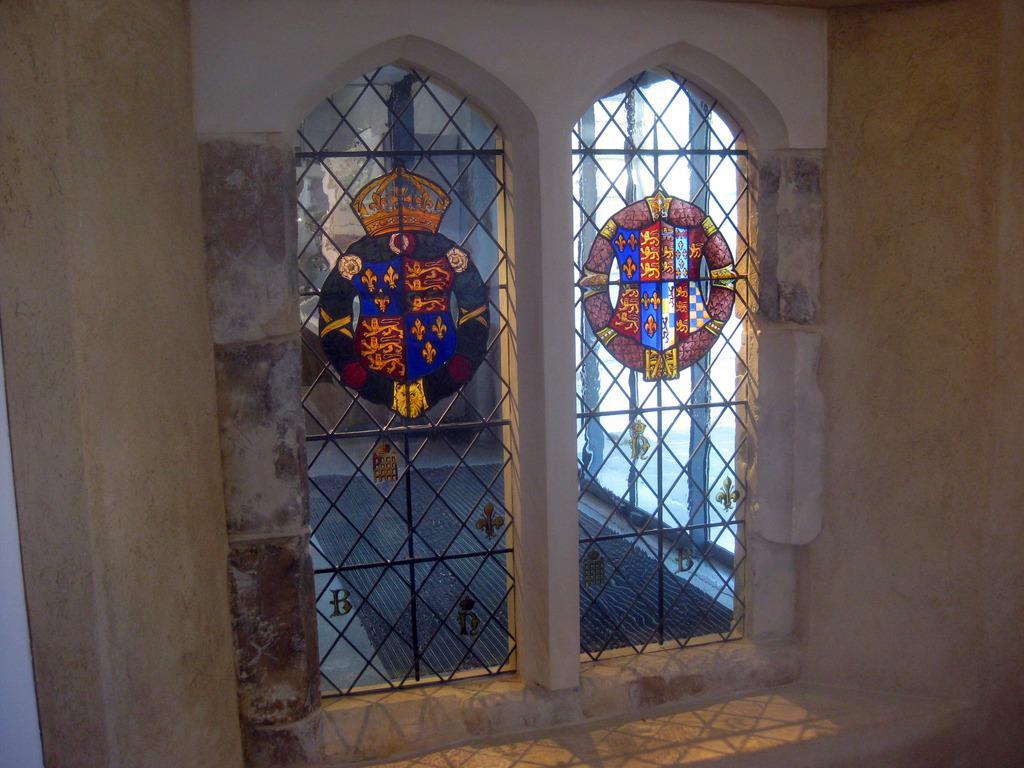Can you describe this image briefly? In this picture I can see windows with glass paintings. I can see iron grilles and some other objects. 